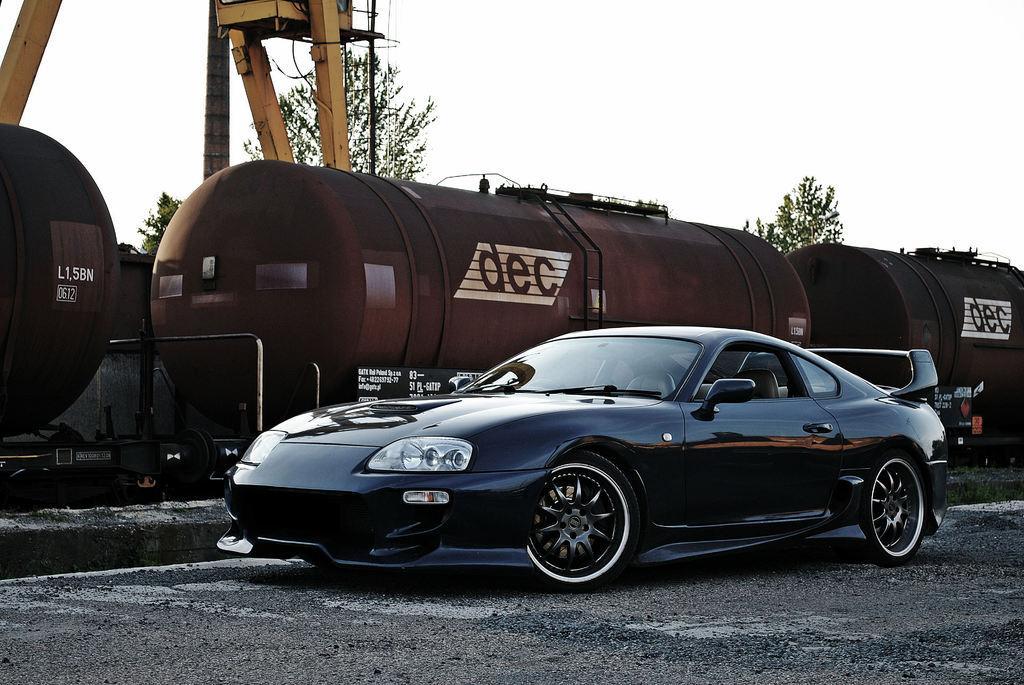Could you give a brief overview of what you see in this image? In this picture we can see a car on the ground, train, wooden poles, trees and some objects and in the background we can see the sky. 